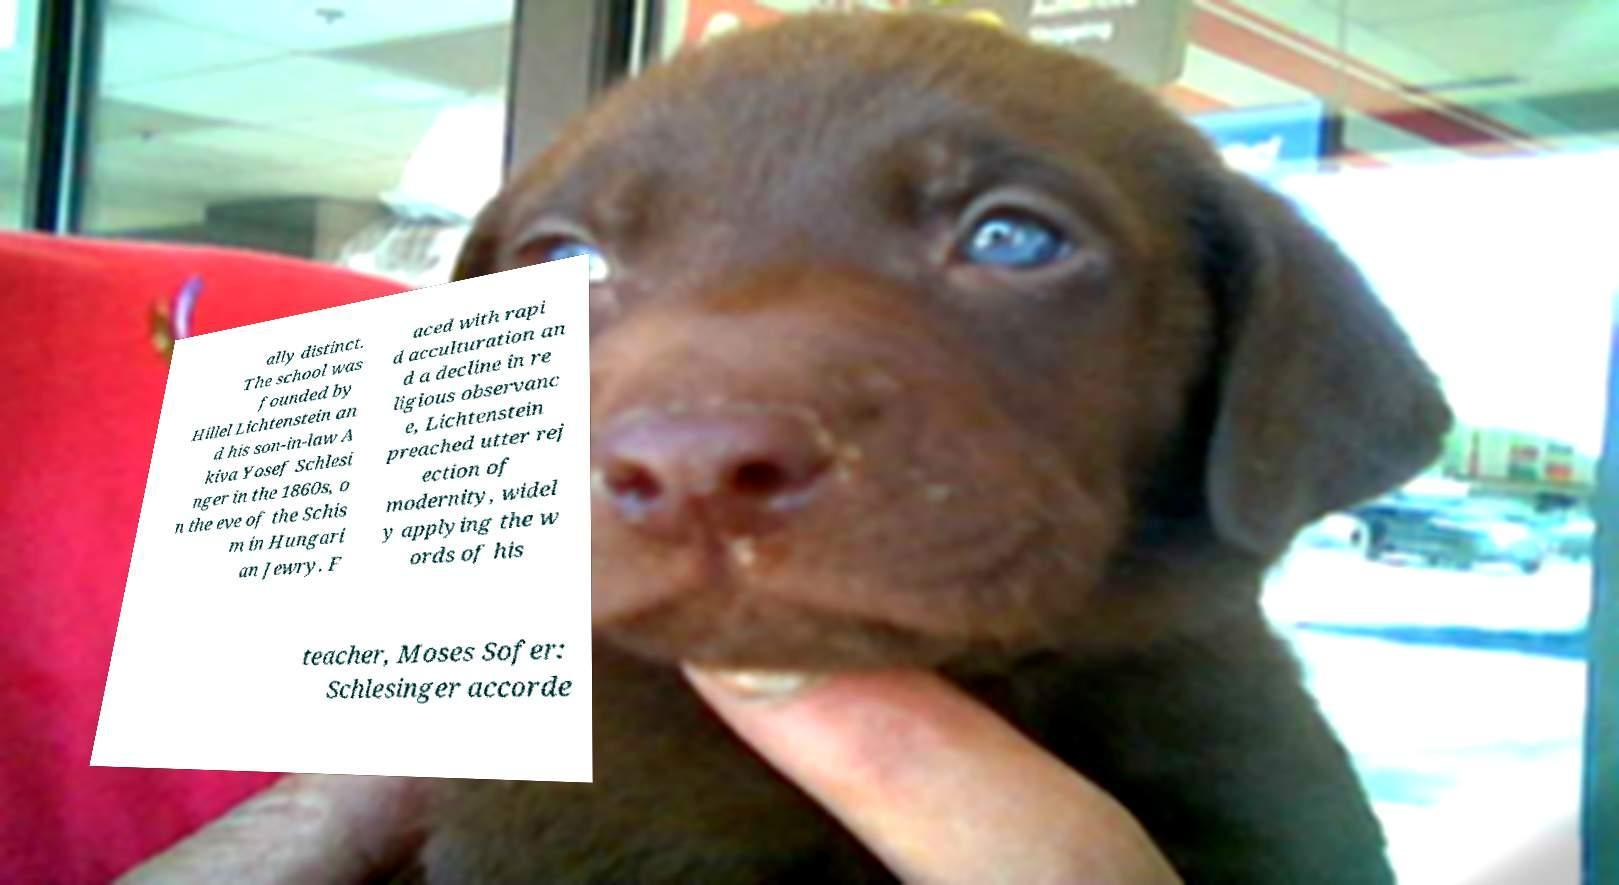Could you extract and type out the text from this image? ally distinct. The school was founded by Hillel Lichtenstein an d his son-in-law A kiva Yosef Schlesi nger in the 1860s, o n the eve of the Schis m in Hungari an Jewry. F aced with rapi d acculturation an d a decline in re ligious observanc e, Lichtenstein preached utter rej ection of modernity, widel y applying the w ords of his teacher, Moses Sofer: Schlesinger accorde 